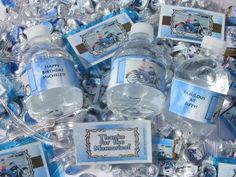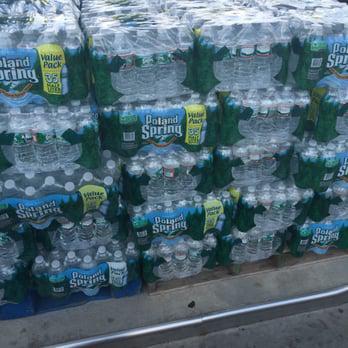The first image is the image on the left, the second image is the image on the right. Given the left and right images, does the statement "many plastic bottles are in large piles" hold true? Answer yes or no. Yes. 